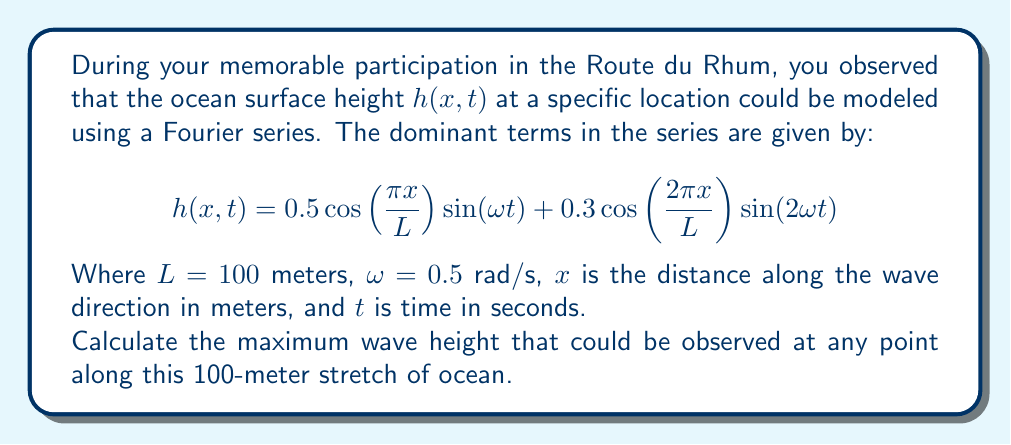Give your solution to this math problem. To solve this problem, we need to follow these steps:

1) The wave height $h(x,t)$ is composed of two terms. To find the maximum possible height, we need to find the maximum value of each term and add them together.

2) For the first term: $0.5 \cos(\frac{\pi x}{L}) \sin(\omega t)$
   - The maximum value of $\cos(\frac{\pi x}{L})$ is 1
   - The maximum value of $\sin(\omega t)$ is 1
   - Therefore, the maximum value of this term is 0.5

3) For the second term: $0.3 \cos(\frac{2\pi x}{L}) \sin(2\omega t)$
   - The maximum value of $\cos(\frac{2\pi x}{L})$ is 1
   - The maximum value of $\sin(2\omega t)$ is 1
   - Therefore, the maximum value of this term is 0.3

4) The maximum possible wave height will occur when both terms reach their maximum values simultaneously. This may not happen in reality, but it represents the theoretical maximum.

5) To get the maximum wave height, we add the maximum values of both terms:
   
   $\text{Maximum Height} = 0.5 + 0.3 = 0.8$ meters

Therefore, the maximum wave height that could be observed is 0.8 meters.
Answer: 0.8 meters 